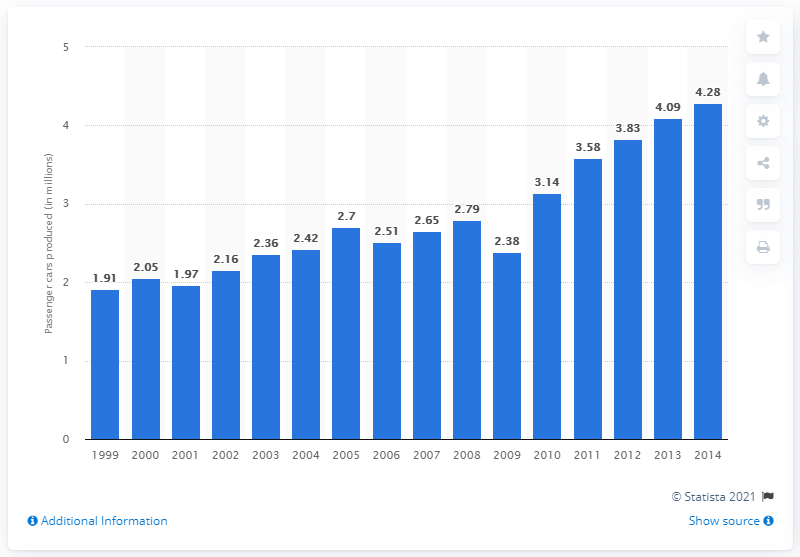Highlight a few significant elements in this photo. In 2013, Nissan produced 4,090,409 passenger cars. 